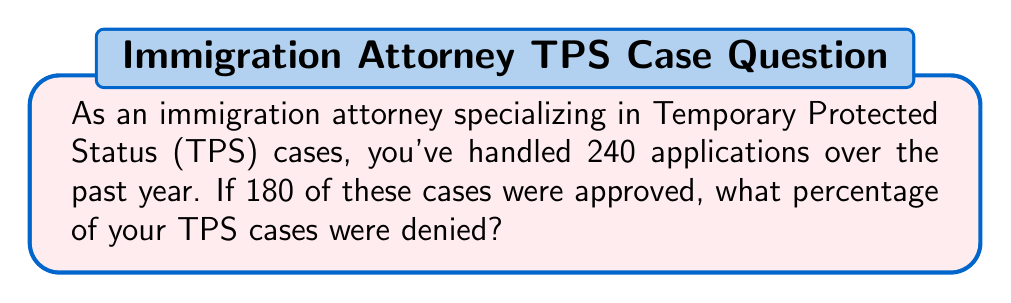Show me your answer to this math problem. To solve this problem, we'll follow these steps:

1. Calculate the number of denied cases:
   Total cases = 240
   Approved cases = 180
   Denied cases = Total cases - Approved cases
   $240 - 180 = 60$ denied cases

2. Calculate the percentage of denied cases:
   Let $x$ be the percentage of denied cases.
   $$x = \frac{\text{Denied cases}}{\text{Total cases}} \times 100\%$$
   
   Substituting the values:
   $$x = \frac{60}{240} \times 100\%$$

3. Simplify the fraction:
   $$x = \frac{1}{4} \times 100\%$$

4. Perform the multiplication:
   $$x = 25\%$$

Therefore, 25% of the TPS cases were denied.
Answer: 25% 